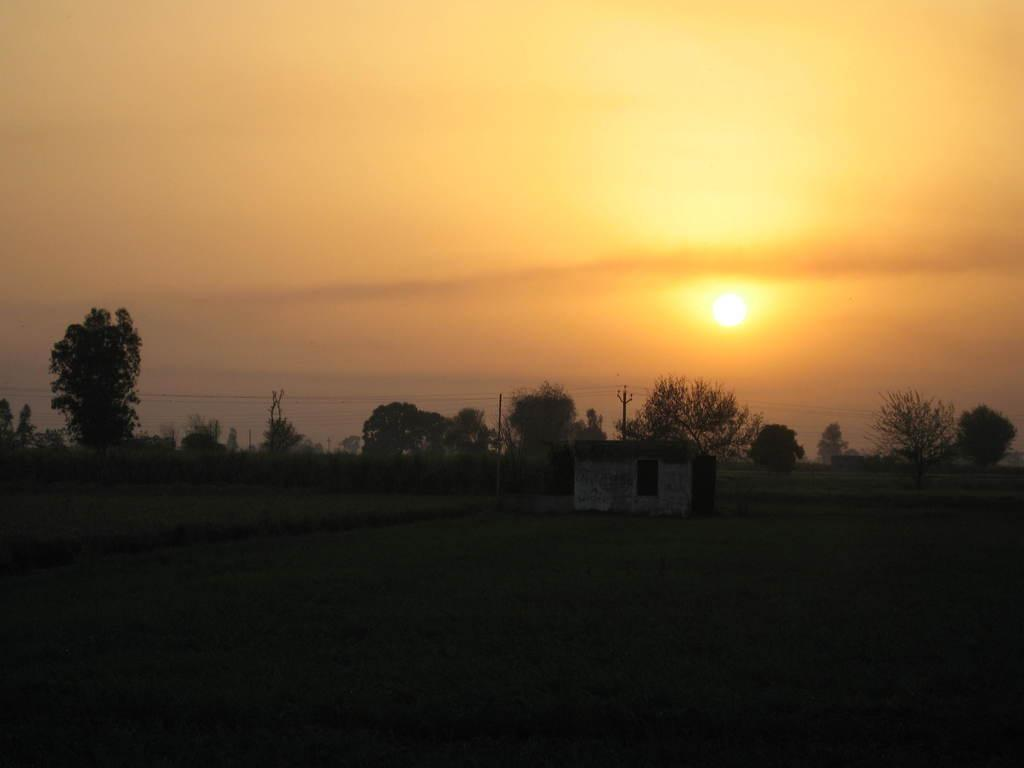What type of structure is present in the image? There is a house in the image. What type of vegetation can be seen in the image? There is grass, a plant, and trees in the image. What man-made objects are present in the image? There are electric wires and an electric pole in the image. What part of the natural environment is visible in the image? The sky is visible in the image. Can you describe the celestial body visible in the sky? The sun is visible in the image. What color is the feather that is flying in the image? There is no feather present in the image. What type of orange can be seen in the image? There is no orange present in the image. 